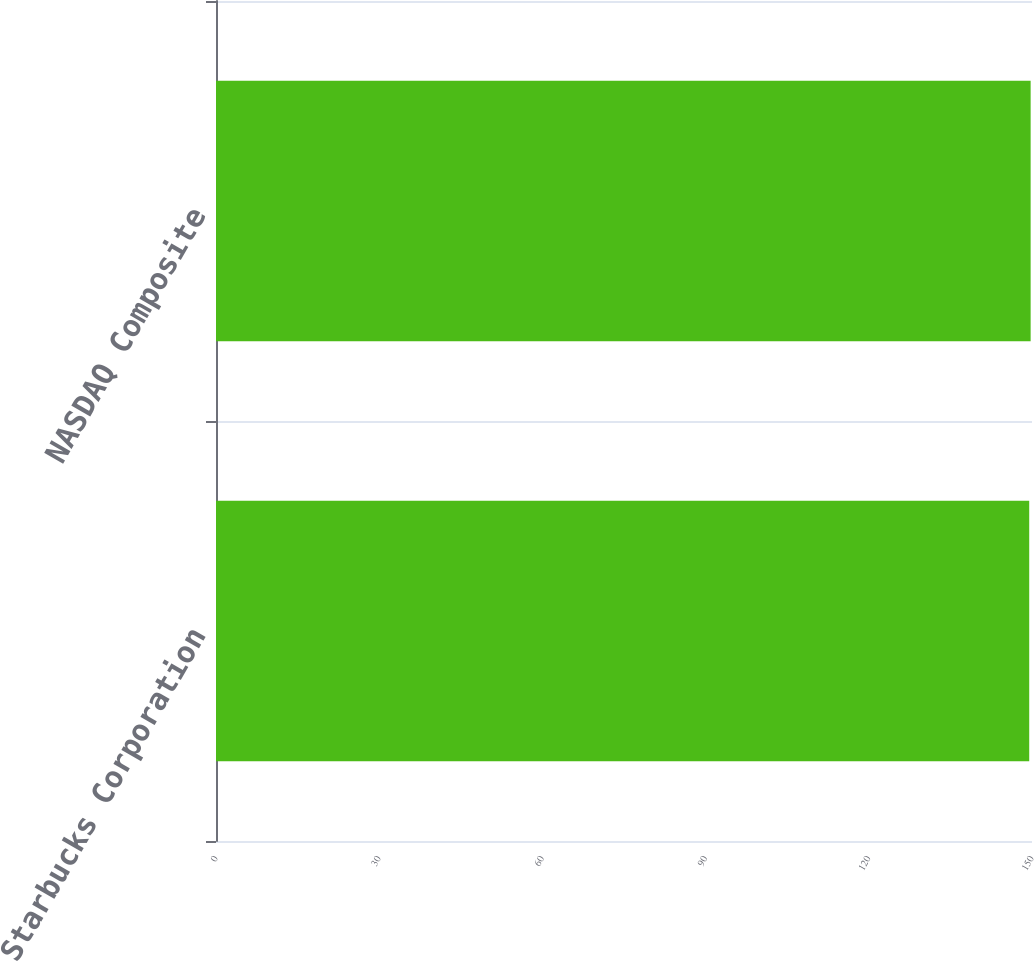Convert chart. <chart><loc_0><loc_0><loc_500><loc_500><bar_chart><fcel>Starbucks Corporation<fcel>NASDAQ Composite<nl><fcel>149.49<fcel>149.75<nl></chart> 